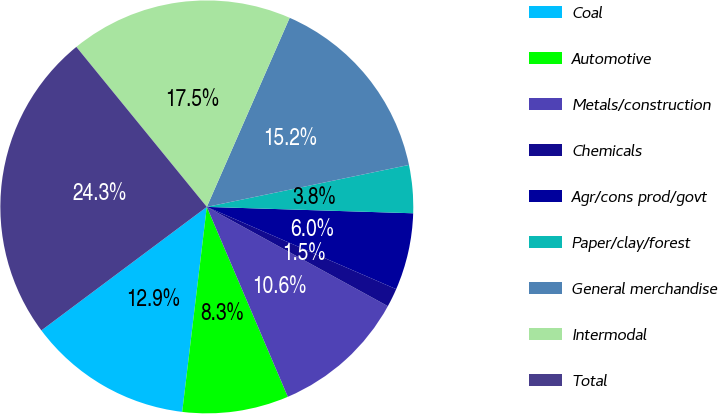Convert chart to OTSL. <chart><loc_0><loc_0><loc_500><loc_500><pie_chart><fcel>Coal<fcel>Automotive<fcel>Metals/construction<fcel>Chemicals<fcel>Agr/cons prod/govt<fcel>Paper/clay/forest<fcel>General merchandise<fcel>Intermodal<fcel>Total<nl><fcel>12.89%<fcel>8.32%<fcel>10.6%<fcel>1.46%<fcel>6.03%<fcel>3.75%<fcel>15.17%<fcel>17.46%<fcel>24.32%<nl></chart> 